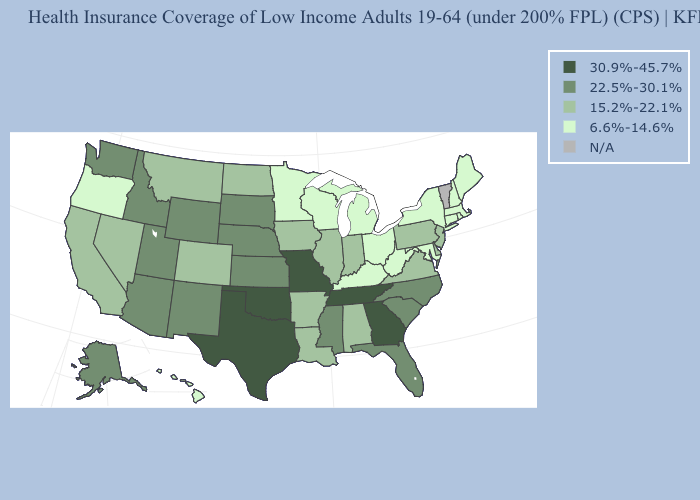Among the states that border Florida , which have the lowest value?
Short answer required. Alabama. Does the first symbol in the legend represent the smallest category?
Quick response, please. No. What is the value of Colorado?
Give a very brief answer. 15.2%-22.1%. Does the map have missing data?
Short answer required. Yes. What is the value of Colorado?
Concise answer only. 15.2%-22.1%. Which states hav the highest value in the West?
Short answer required. Alaska, Arizona, Idaho, New Mexico, Utah, Washington, Wyoming. Name the states that have a value in the range N/A?
Be succinct. Vermont. Does Maine have the lowest value in the USA?
Write a very short answer. Yes. Does the first symbol in the legend represent the smallest category?
Write a very short answer. No. Name the states that have a value in the range 30.9%-45.7%?
Give a very brief answer. Georgia, Missouri, Oklahoma, Tennessee, Texas. What is the value of Missouri?
Quick response, please. 30.9%-45.7%. What is the lowest value in states that border New Jersey?
Give a very brief answer. 6.6%-14.6%. Name the states that have a value in the range 30.9%-45.7%?
Write a very short answer. Georgia, Missouri, Oklahoma, Tennessee, Texas. How many symbols are there in the legend?
Keep it brief. 5. 